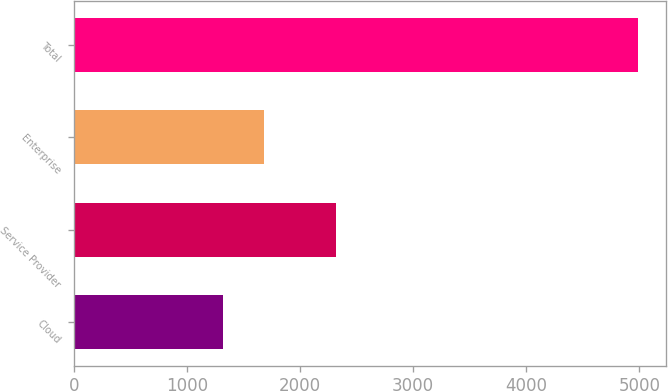Convert chart. <chart><loc_0><loc_0><loc_500><loc_500><bar_chart><fcel>Cloud<fcel>Service Provider<fcel>Enterprise<fcel>Total<nl><fcel>1315.9<fcel>2316.4<fcel>1683.32<fcel>4990.1<nl></chart> 